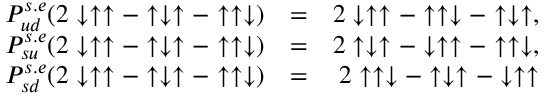Convert formula to latex. <formula><loc_0><loc_0><loc_500><loc_500>\begin{array} { r l r } { P _ { u d } ^ { s . e } ( 2 \downarrow \uparrow \uparrow - \uparrow \downarrow \uparrow - \uparrow \uparrow \downarrow ) } & { = } & { 2 \downarrow \uparrow \uparrow - \uparrow \uparrow \downarrow - \uparrow \downarrow \uparrow , } \\ { P _ { s u } ^ { s . e } ( 2 \downarrow \uparrow \uparrow - \uparrow \downarrow \uparrow - \uparrow \uparrow \downarrow ) } & { = } & { 2 \uparrow \downarrow \uparrow - \downarrow \uparrow \uparrow - \uparrow \uparrow \downarrow , } \\ { P _ { s d } ^ { s . e } ( 2 \downarrow \uparrow \uparrow - \uparrow \downarrow \uparrow - \uparrow \uparrow \downarrow ) } & { = } & { 2 \uparrow \uparrow \downarrow - \uparrow \downarrow \uparrow - \downarrow \uparrow \uparrow } \end{array}</formula> 